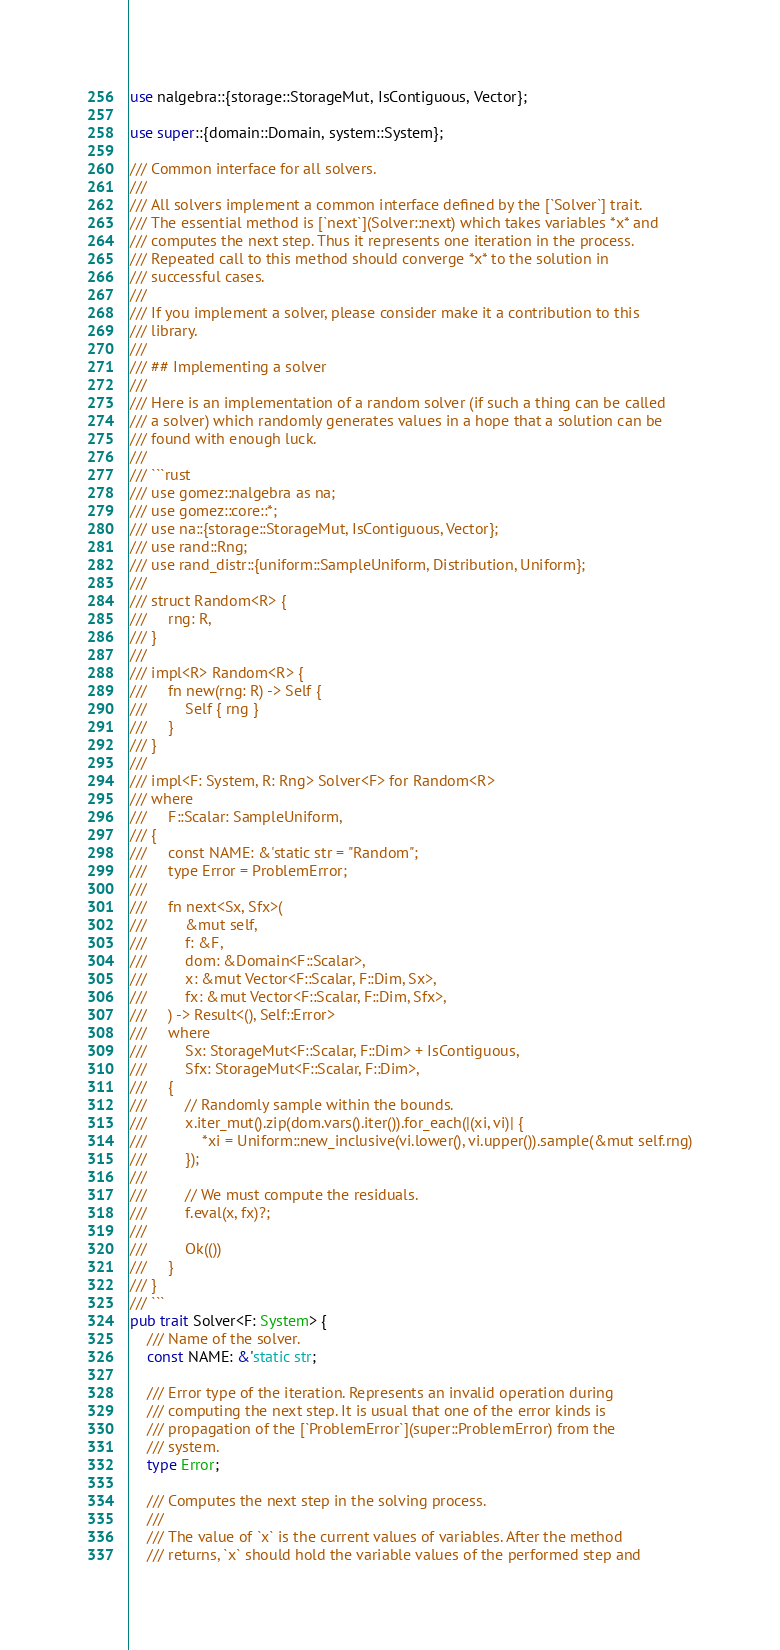<code> <loc_0><loc_0><loc_500><loc_500><_Rust_>use nalgebra::{storage::StorageMut, IsContiguous, Vector};

use super::{domain::Domain, system::System};

/// Common interface for all solvers.
///
/// All solvers implement a common interface defined by the [`Solver`] trait.
/// The essential method is [`next`](Solver::next) which takes variables *x* and
/// computes the next step. Thus it represents one iteration in the process.
/// Repeated call to this method should converge *x* to the solution in
/// successful cases.
///
/// If you implement a solver, please consider make it a contribution to this
/// library.
///
/// ## Implementing a solver
///
/// Here is an implementation of a random solver (if such a thing can be called
/// a solver) which randomly generates values in a hope that a solution can be
/// found with enough luck.
///
/// ```rust
/// use gomez::nalgebra as na;
/// use gomez::core::*;
/// use na::{storage::StorageMut, IsContiguous, Vector};
/// use rand::Rng;
/// use rand_distr::{uniform::SampleUniform, Distribution, Uniform};
///
/// struct Random<R> {
///     rng: R,
/// }
///
/// impl<R> Random<R> {
///     fn new(rng: R) -> Self {
///         Self { rng }
///     }
/// }
///
/// impl<F: System, R: Rng> Solver<F> for Random<R>
/// where
///     F::Scalar: SampleUniform,
/// {
///     const NAME: &'static str = "Random";
///     type Error = ProblemError;
///
///     fn next<Sx, Sfx>(
///         &mut self,
///         f: &F,
///         dom: &Domain<F::Scalar>,
///         x: &mut Vector<F::Scalar, F::Dim, Sx>,
///         fx: &mut Vector<F::Scalar, F::Dim, Sfx>,
///     ) -> Result<(), Self::Error>
///     where
///         Sx: StorageMut<F::Scalar, F::Dim> + IsContiguous,
///         Sfx: StorageMut<F::Scalar, F::Dim>,
///     {
///         // Randomly sample within the bounds.
///         x.iter_mut().zip(dom.vars().iter()).for_each(|(xi, vi)| {
///             *xi = Uniform::new_inclusive(vi.lower(), vi.upper()).sample(&mut self.rng)
///         });
///
///         // We must compute the residuals.
///         f.eval(x, fx)?;
///
///         Ok(())
///     }
/// }
/// ```
pub trait Solver<F: System> {
    /// Name of the solver.
    const NAME: &'static str;

    /// Error type of the iteration. Represents an invalid operation during
    /// computing the next step. It is usual that one of the error kinds is
    /// propagation of the [`ProblemError`](super::ProblemError) from the
    /// system.
    type Error;

    /// Computes the next step in the solving process.
    ///
    /// The value of `x` is the current values of variables. After the method
    /// returns, `x` should hold the variable values of the performed step and</code> 